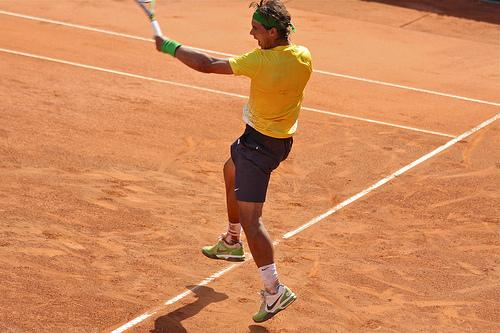What sport is being played in the image and what is the player wearing? Tennis is being played, and the player is wearing a yellow shirt, black shorts, green headband, green wristband, white socks, and green and white shoes. Identify the main subject and their clothing in the image. A male tennis player in a yellow shirt, black shorts, green headband, green wristband, white socks, and green and white shoes is on a clay court. Describe the main character and his attire in the image. A man with brown hair and tan legs is dressed as a tennis player with a yellow shirt, black shorts, green and white shoes, and green accessories. Give a concise description of the scene in the image. A tennis player is in action on a clay court, wearing a yellow shirt, black shorts, and green and white shoes, holding a racket with white grip. Describe what the individual in the image is doing and their outfit. A man is swinging a tennis racket on a clay court, dressed in a yellow shirt, black shorts, green headband, green wristband, white socks, and green and white shoes. Provide a brief overview of the primary elements in the image. A male tennis player in a yellow shirt and black shorts is swinging a racket on a clay court with white lines. Explain the tennis player's outfit in the image. The player is wearing a black and yellow outfit, green headband, green wristband, white socks, and green and white Nike tennis shoes. Briefly describe the tennis player's physical appearance and attire. The tennis player has brown hair, tan legs, and is wearing a yellow shirt, black shorts, green accessories, and green and white shoes. Mention the player and the surface he's playing on in the image. A male tennis player is in action on a clay court, wearing a yellow shirt, black shorts, and sporting green and white accessories. Mention the colors and features of the tennis player's attire. The tennis player is wearing a yellow tee, black shorts, green headband, green wristband, white socks, and green and white Nike shoes. 